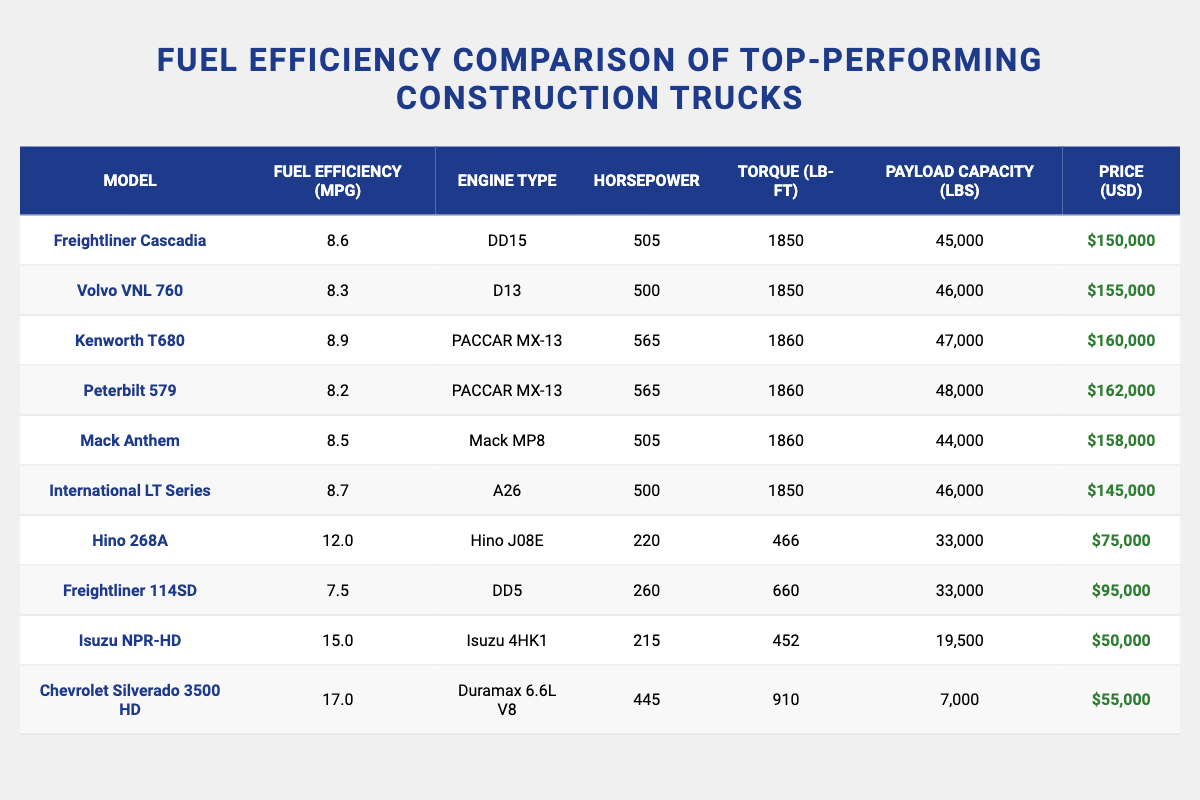What is the fuel efficiency of the Kenworth T680? The table lists the fuel efficiency of the Kenworth T680 as 8.9 MPG.
Answer: 8.9 MPG Which truck has the highest horsepower? The table shows that the Kenworth T680 has the highest horsepower of 565.
Answer: Kenworth T680 What is the total payload capacity of all trucks listed? The payload capacities are 45000 + 46000 + 47000 + 48000 + 44000 + 46000 + 33000 + 33000 + 19500 + 7000 = 400000 lbs.
Answer: 400000 lbs Is the Freightliner Cascadia more fuel-efficient than the Mack Anthem? The table shows that the fuel efficiency of the Freightliner Cascadia is 8.6 MPG, whereas the Mack Anthem is 8.5 MPG, indicating the Cascadia is indeed more efficient.
Answer: Yes What is the average price of the trucks listed? Summing the prices gives $150000 + $155000 + $160000 + $162000 + $158000 + $145000 + $75000 + $95000 + $50000 + $55000 = $1,250,000. Dividing by 10 trucks results in an average price of $125000.
Answer: $125000 How much more does the Chevrolet Silverado 3500 HD cost compared to the Hino 268A? The Chevrolet Silverado 3500 HD costs $55000 while the Hino 268A costs $75000. Thus, $55000 - $75000 = -$20000, meaning it costs $20000 less.
Answer: $20000 less What percentage of trucks have a fuel efficiency greater than 8 MPG? The trucks with fuel efficiency greater than 8 MPG are the Freightliner Cascadia, Kenworth T680, International LT Series, and Hino 268A, totaling 4 trucks out of 10, which is (4/10)*100 = 40%.
Answer: 40% Which truck has the lowest price per MPG? The prices per MPG for the relevant trucks can be calculated: For the Isuzu NPR-HD, it costs $50000 / 15.0 = $3333.33 per MPG; and for Chevrolet Silverado 3500 HD, it costs $55000 / 17.0 = $3235.29 per MPG. The lowest is Isuzu NPR-HD.
Answer: Isuzu NPR-HD 